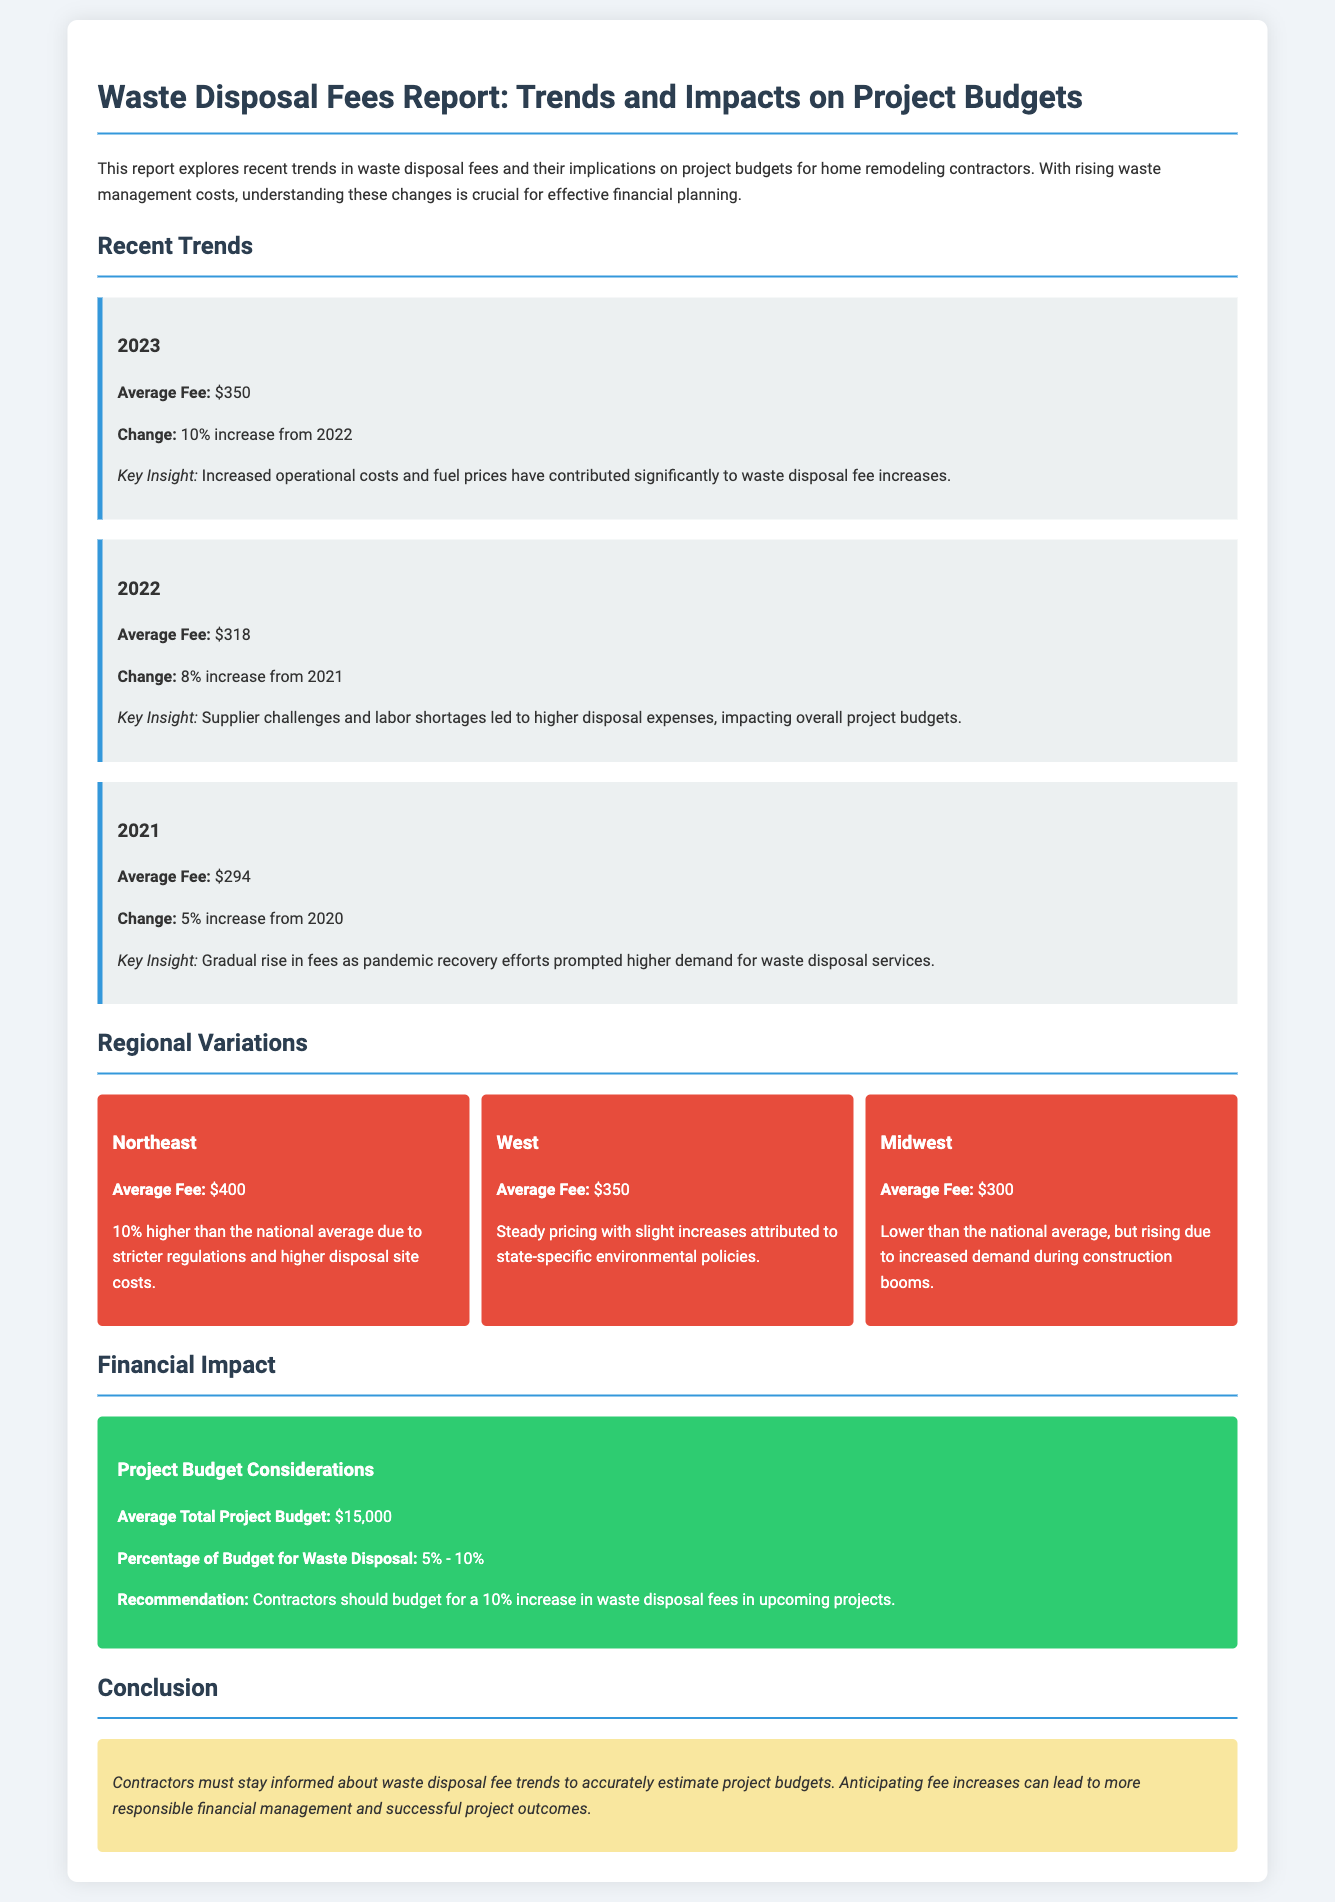What is the average fee for waste disposal in 2023? The average fee for waste disposal in 2023 is specified in the report under recent trends.
Answer: $350 What was the percentage increase in waste disposal fees from 2022 to 2023? The percentage increase from 2022 to 2023 is highlighted as a key change in the trends section of the report.
Answer: 10% What was the average disposal fee in the Northeast region? The Northeast region's average fee is detailed in the regional variations section of the report.
Answer: $400 What percentage of the project budget should contractors budget for waste disposal fees? This recommendation is provided in the financial impact section, which discusses budget considerations for contractors.
Answer: 5% - 10% What was the average fee for waste disposal in 2022? The report lists the average fee for waste disposal for 2022 under recent trends.
Answer: $318 What key factor contributed to the increase in waste disposal fees in 2023? The report provides insights into key factors impacting fee increases in the discussion on trends, specifically for 2023.
Answer: Increased operational costs What are the average total project budgets mentioned in the report? This average is presented in the financial impact section as part of budget considerations for contractors.
Answer: $15,000 What change percentage was reported for waste disposal fees from 2021 to 2022? The report mentions this percentage change in the trends section that outlines yearly changes.
Answer: 8% What major issue affected waste disposal expenses in 2022? The report identifies specific challenges in the trends section that impacted waste disposal expenses for that year.
Answer: Supplier challenges and labor shortages 